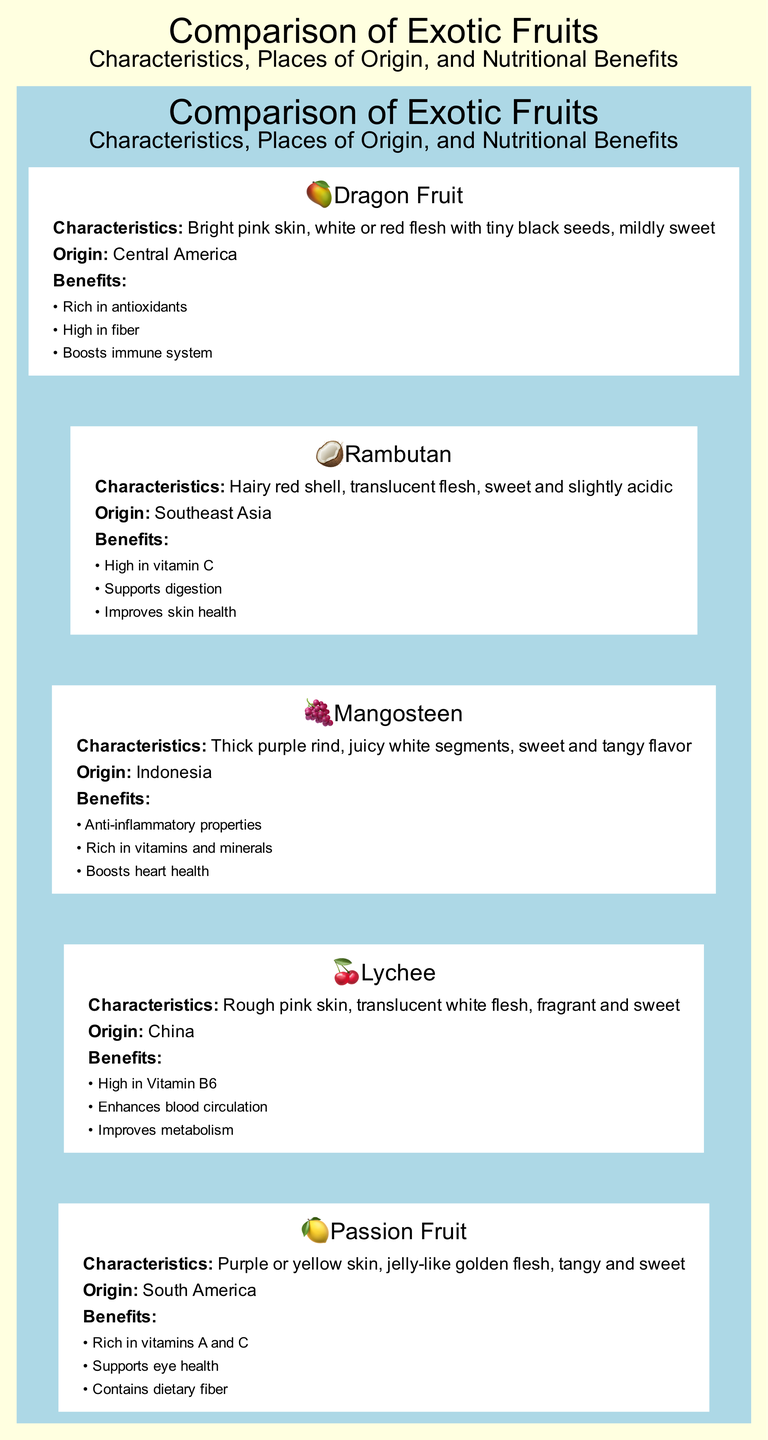What is the origin of Dragon Fruit? The diagram shows that Dragon Fruit is listed under the 'Origin' category with the value 'Central America'. This information is directly associated with the Dragon Fruit node.
Answer: Central America Which fruit has a jelly-like golden flesh? The diagram indicates that Passion Fruit is described with the characteristic of having a 'jelly-like golden flesh'. This information is found under the Passion Fruit node.
Answer: Passion Fruit How many nutritional benefits are listed for Rambutan? By examining the Rambutan node in the diagram, we can see that there are three bullet points listed under 'Benefits'. Each bullet point corresponds to one nutritional benefit.
Answer: 3 What color is the skin of Mangosteen? The diagram states that Mangosteen has a 'Thick purple rind' as one of its characteristics. This detail is clearly mentioned in the Mangosteen section.
Answer: Purple Which fruit has high antioxidant content? The diagram indicates that Dragon Fruit is associated with 'Rich in antioxidants', making it the fruit that has this nutritional benefit. This information is directly related to the Dragon Fruit node.
Answer: Dragon Fruit Which fruit is native to Southeast Asia? The diagram specifies that Rambutan has its origin in 'Southeast Asia', thus identifying it as the fruit native to that region. This detail is in the 'Origin' section for Rambutan.
Answer: Rambutan What nutrient does Lychee enhance for health? According to the diagram, Lychee 'Enhances blood circulation' as one of its nutritional benefits. This benefit is clearly listed in the Lychee node.
Answer: Blood circulation How many fruits are included in the comparison chart? Counting the nodes presented in the diagram, there are five distinct fruits listed: Dragon Fruit, Rambutan, Mangosteen, Lychee, and Passion Fruit. Therefore, the total number of fruits is five.
Answer: 5 